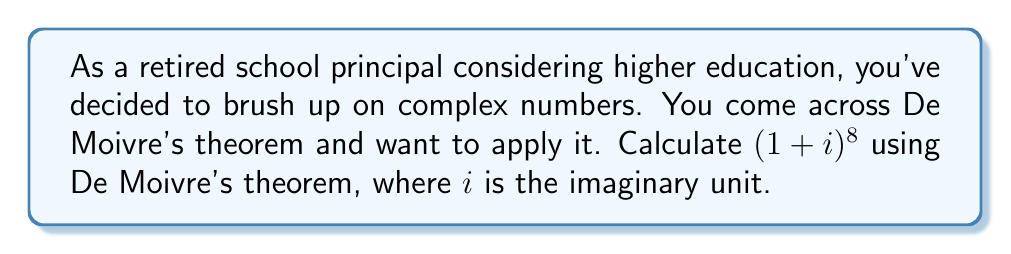Help me with this question. Let's approach this step-by-step using De Moivre's theorem:

1) First, we need to express $1+i$ in polar form: $r(\cos\theta + i\sin\theta)$

2) To find $r$, we calculate the modulus:
   $r = \sqrt{1^2 + 1^2} = \sqrt{2}$

3) To find $\theta$, we calculate the argument:
   $\theta = \arctan(\frac{1}{1}) = \frac{\pi}{4}$

4) So, $1+i = \sqrt{2}(\cos\frac{\pi}{4} + i\sin\frac{\pi}{4})$

5) Now, we can apply De Moivre's theorem:
   $$(1+i)^8 = (\sqrt{2})^8 (\cos\frac{8\pi}{4} + i\sin\frac{8\pi}{4})$$

6) Simplify the power of $\sqrt{2}$:
   $(\sqrt{2})^8 = 2^4 = 16$

7) Simplify the angle:
   $\frac{8\pi}{4} = 2\pi$

8) Remember that $\cos 2\pi = 1$ and $\sin 2\pi = 0$

9) Therefore:
   $$(1+i)^8 = 16(\cos 2\pi + i\sin 2\pi) = 16(1 + 0i) = 16$$
Answer: $$(1+i)^8 = 16$$ 